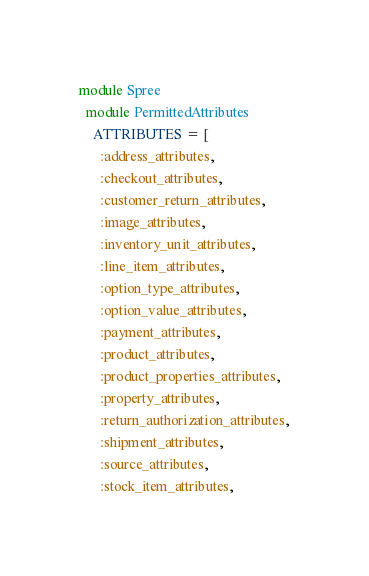<code> <loc_0><loc_0><loc_500><loc_500><_Ruby_>module Spree
  module PermittedAttributes
    ATTRIBUTES = [
      :address_attributes,
      :checkout_attributes,
      :customer_return_attributes,
      :image_attributes,
      :inventory_unit_attributes,
      :line_item_attributes,
      :option_type_attributes,
      :option_value_attributes,
      :payment_attributes,
      :product_attributes,
      :product_properties_attributes,
      :property_attributes,
      :return_authorization_attributes,
      :shipment_attributes,
      :source_attributes,
      :stock_item_attributes,</code> 